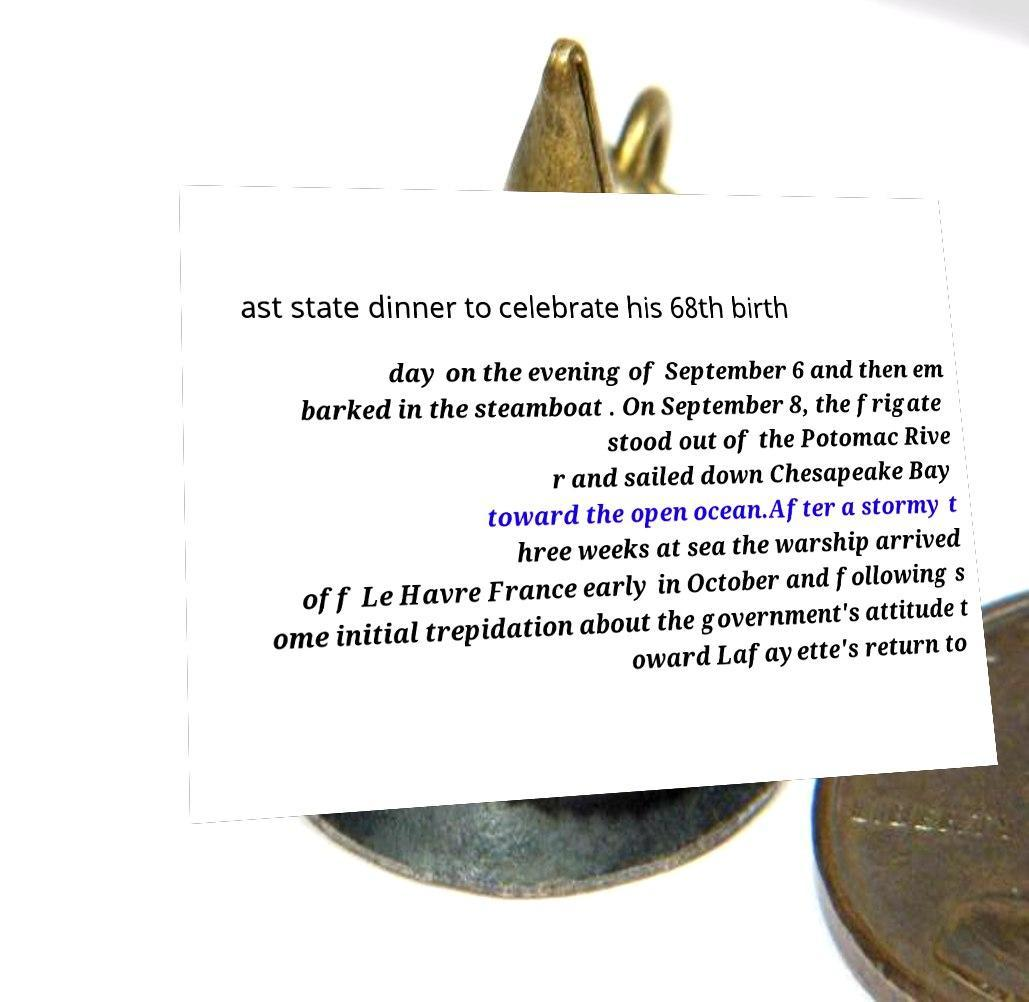For documentation purposes, I need the text within this image transcribed. Could you provide that? ast state dinner to celebrate his 68th birth day on the evening of September 6 and then em barked in the steamboat . On September 8, the frigate stood out of the Potomac Rive r and sailed down Chesapeake Bay toward the open ocean.After a stormy t hree weeks at sea the warship arrived off Le Havre France early in October and following s ome initial trepidation about the government's attitude t oward Lafayette's return to 